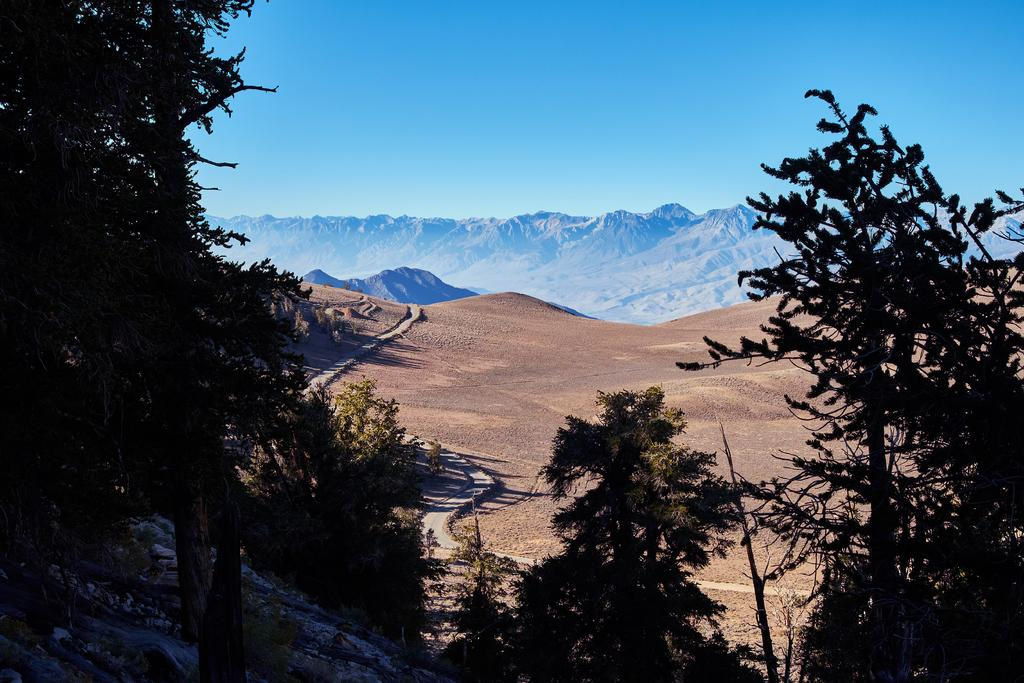What can be seen on the ground in the image? There is a pathway on the ground in the image. What type of vegetation is present in the image? There is a group of trees in the image. What can be seen in the distance in the image? There are mountains visible in the background of the image. What is visible in the sky in the image? The sky is visible in the image. How would you describe the weather based on the appearance of the sky? The sky appears cloudy in the image. What type of vegetable is being served at the party in the image? There is no party or vegetable present in the image. How does the heat affect the mountains in the image? There is no indication of heat or its effects on the mountains in the image. 